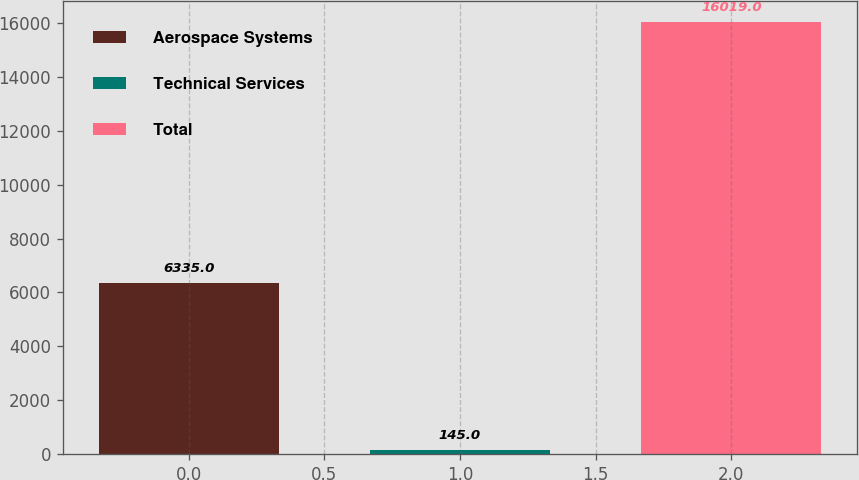Convert chart to OTSL. <chart><loc_0><loc_0><loc_500><loc_500><bar_chart><fcel>Aerospace Systems<fcel>Technical Services<fcel>Total<nl><fcel>6335<fcel>145<fcel>16019<nl></chart> 